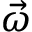<formula> <loc_0><loc_0><loc_500><loc_500>\vec { \omega }</formula> 